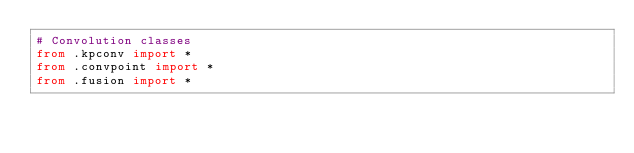Convert code to text. <code><loc_0><loc_0><loc_500><loc_500><_Python_># Convolution classes
from .kpconv import *
from .convpoint import *
from .fusion import *</code> 